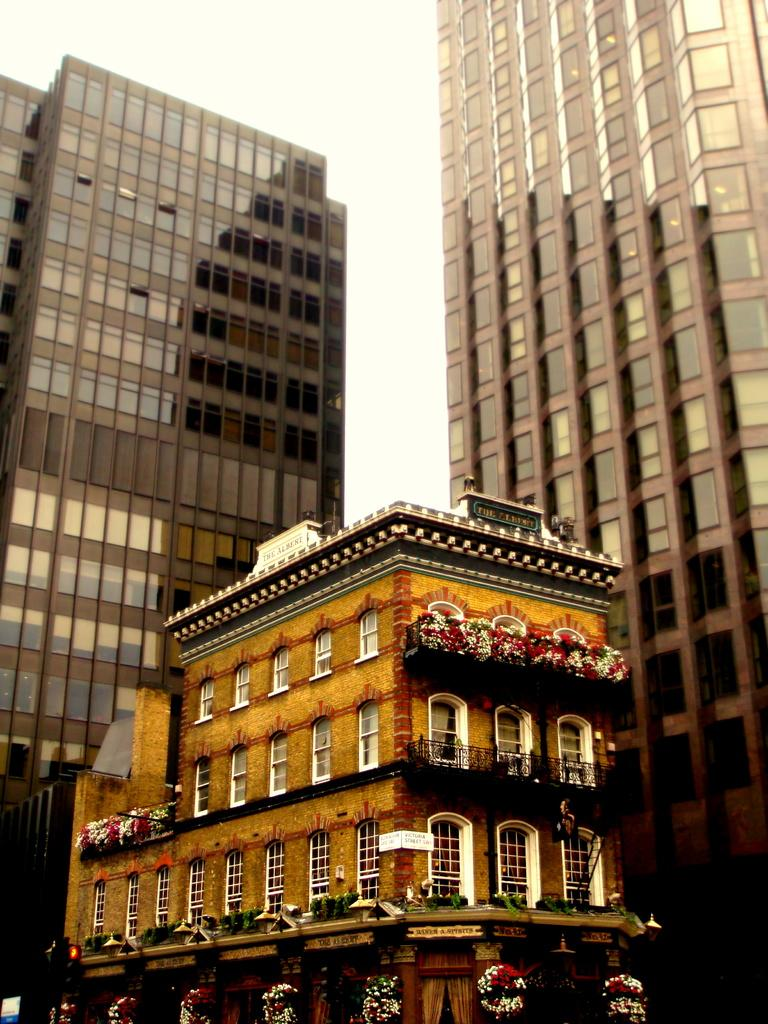What type of structures can be seen in the image? There are buildings in the image. Can you describe any specific features of the buildings? Yes, there are flowers on the building in the front. What type of tree is growing in the building? There is no tree growing in the building; the image only shows flowers on the building in the front. 